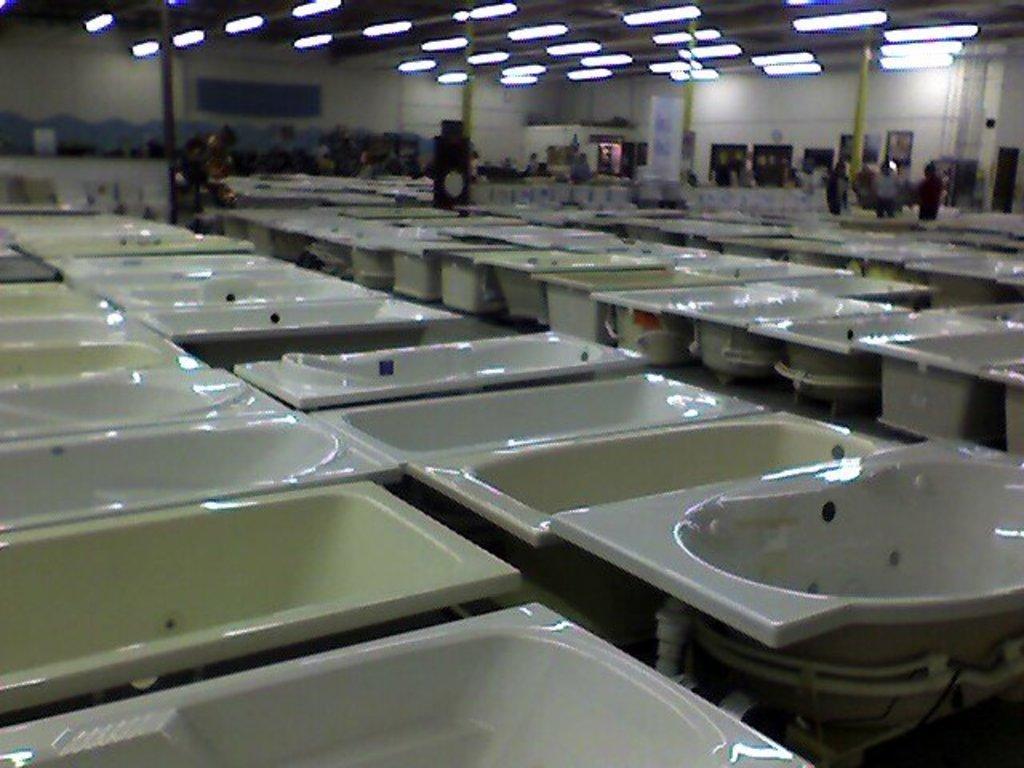Describe this image in one or two sentences. This picture contains many wash basins placed in a row. There are many people standing in the background. Behind them, we see a wall which is white in color. At the top of the picture, we see the lights and the ceiling of the room. 